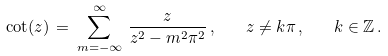Convert formula to latex. <formula><loc_0><loc_0><loc_500><loc_500>\cot ( z ) \, = \, \sum _ { m = - \infty } ^ { \infty } \, \frac { z } { z ^ { 2 } - m ^ { 2 } \pi ^ { 2 } } \, , \quad z \ne k \pi \, , \quad k \in \mathbb { Z } \, .</formula> 